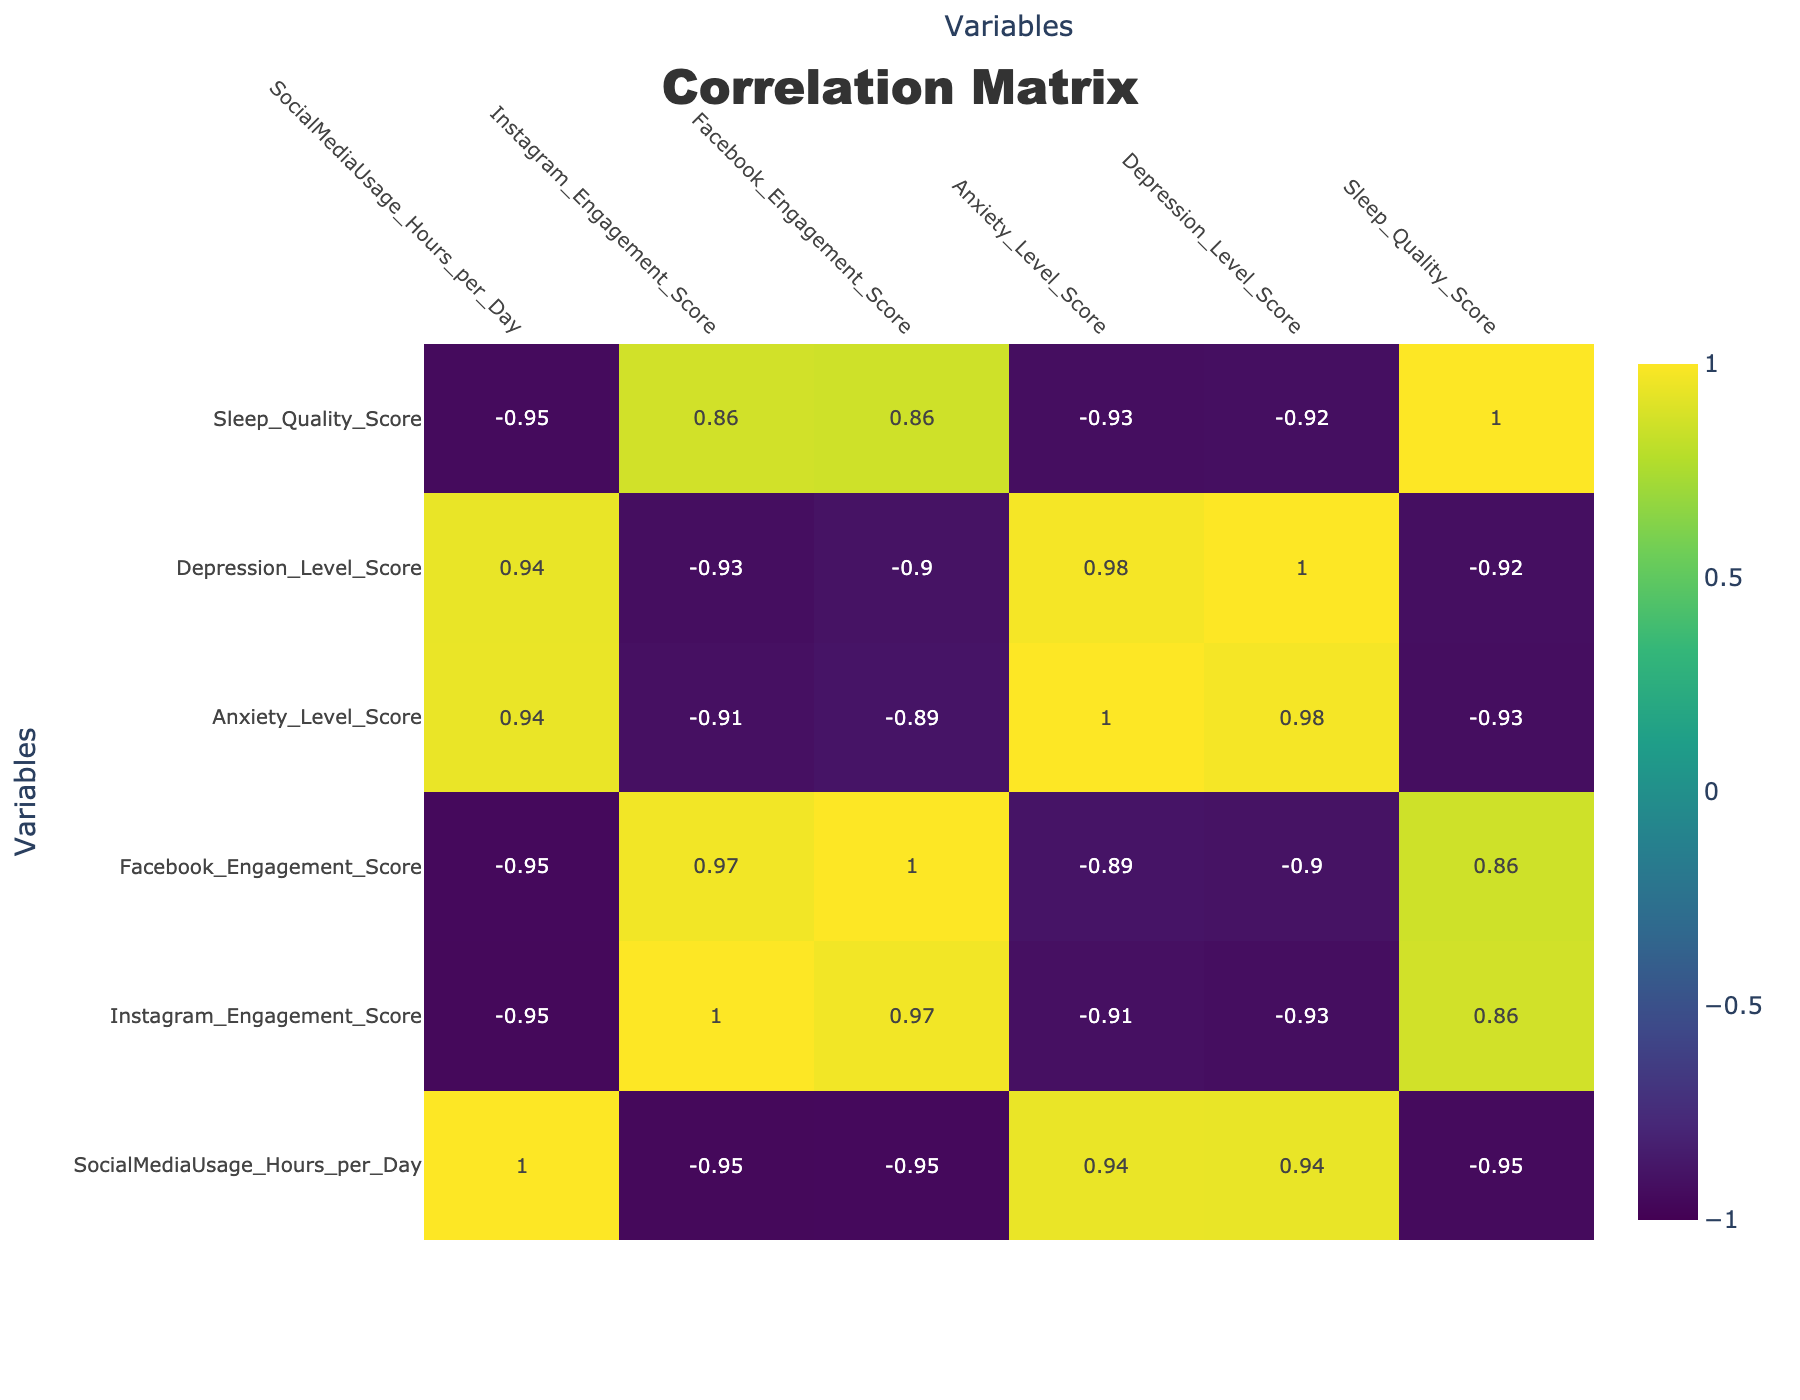What is the correlation between social media usage and anxiety level? The correlation coefficient between social media usage hours per day and anxiety level score can be found in the correlation table. A positive correlation means as social media usage increases, anxiety levels might increase as well. According to the table, this correlation value is 0.682, indicating a moderate positive correlation.
Answer: 0.682 What is the engagement score for Instagram with the highest correlation to sleep quality score? To find the engagement score for Instagram that correlates most with sleep quality, we look at the correlation values in the table. The correlation between Instagram engagement score and sleep quality score is -0.778, which shows a significant negative correlation. The highest engagement score for Instagram in the dataset is 95, with the lowest sleep quality score of 3.
Answer: 95 Is there a significant negative correlation between Facebook engagement score and depression level score? Checking the correlation table, the correlation value between Facebook engagement score and depression level score is -0.786, which indicates a significant negative correlation. This means that as Facebook engagement increases, depression levels tend to decrease.
Answer: Yes What is the average anxiety level score for users engaging with Instagram scores above 80? We must first identify the users with Instagram engagement scores above 80. In the dataset, those are the first, second, and ninth entries. Their anxiety level scores are 7, 6, and 3 respectively. The average is calculated as (7 + 6 + 3) / 3 = 5.33.
Answer: 5.33 If social media usage increases by one hour per day, what do we expect the anxiety level score to change by? We refer to the correlation value between social media usage hours per day and anxiety level, which is 0.682. A change of one hour in social media usage suggests an average increase of 0.682 in anxiety level scores.
Answer: 0.682 